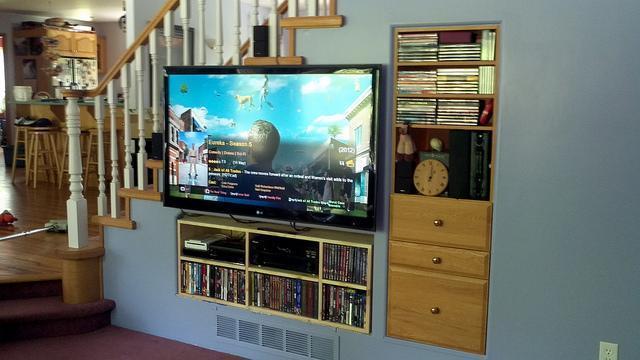Is the statement "The tv is away from the dining table." accurate regarding the image?
Answer yes or no. Yes. 